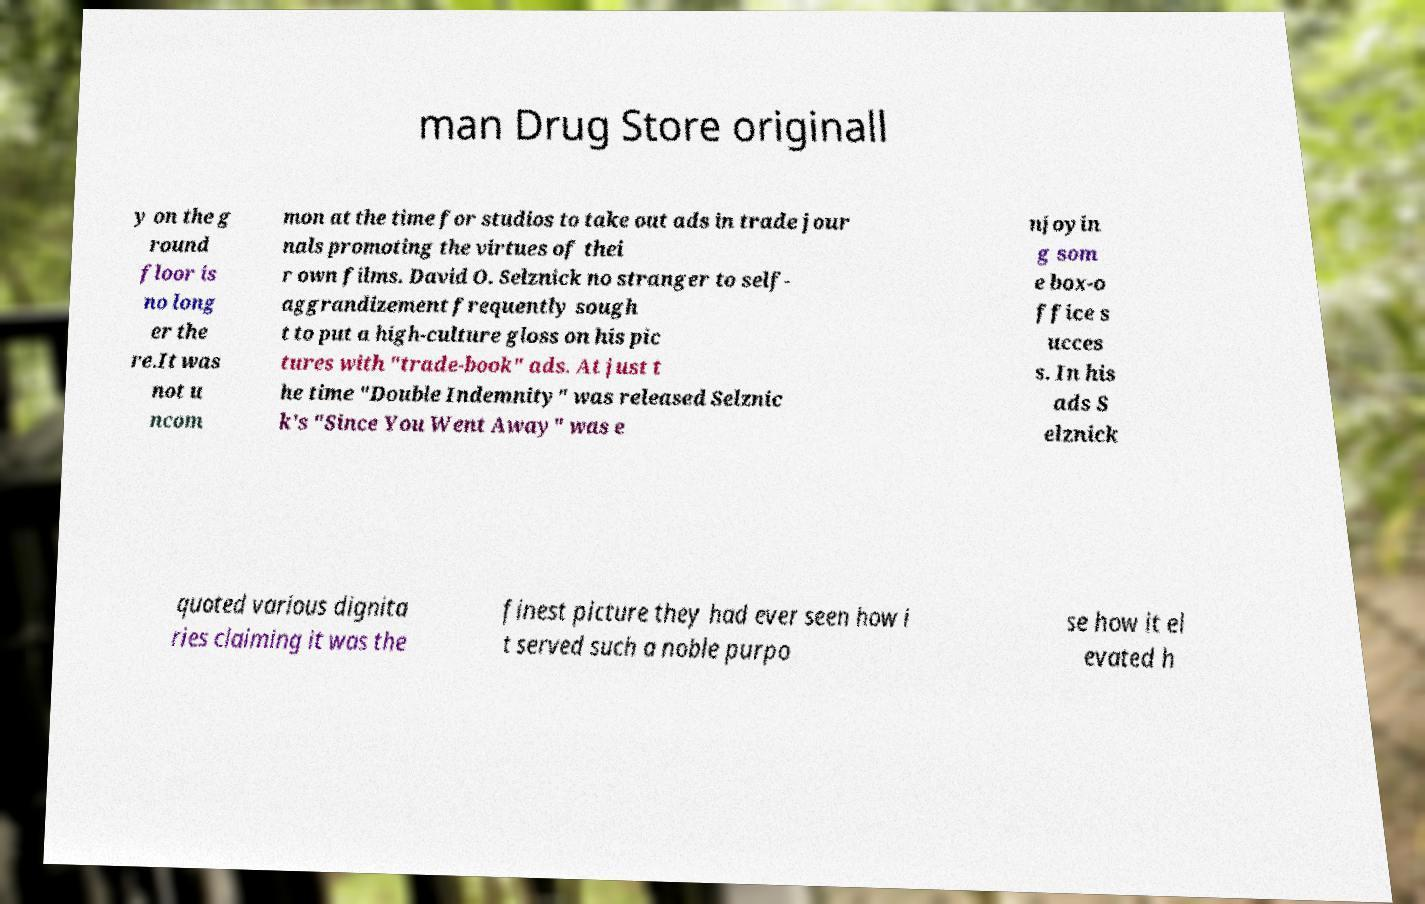Can you read and provide the text displayed in the image?This photo seems to have some interesting text. Can you extract and type it out for me? man Drug Store originall y on the g round floor is no long er the re.It was not u ncom mon at the time for studios to take out ads in trade jour nals promoting the virtues of thei r own films. David O. Selznick no stranger to self- aggrandizement frequently sough t to put a high-culture gloss on his pic tures with "trade-book" ads. At just t he time "Double Indemnity" was released Selznic k's "Since You Went Away" was e njoyin g som e box-o ffice s ucces s. In his ads S elznick quoted various dignita ries claiming it was the finest picture they had ever seen how i t served such a noble purpo se how it el evated h 